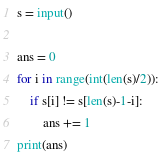Convert code to text. <code><loc_0><loc_0><loc_500><loc_500><_Python_>s = input()

ans = 0
for i in range(int(len(s)/2)):
    if s[i] != s[len(s)-1-i]:
        ans += 1
print(ans)</code> 